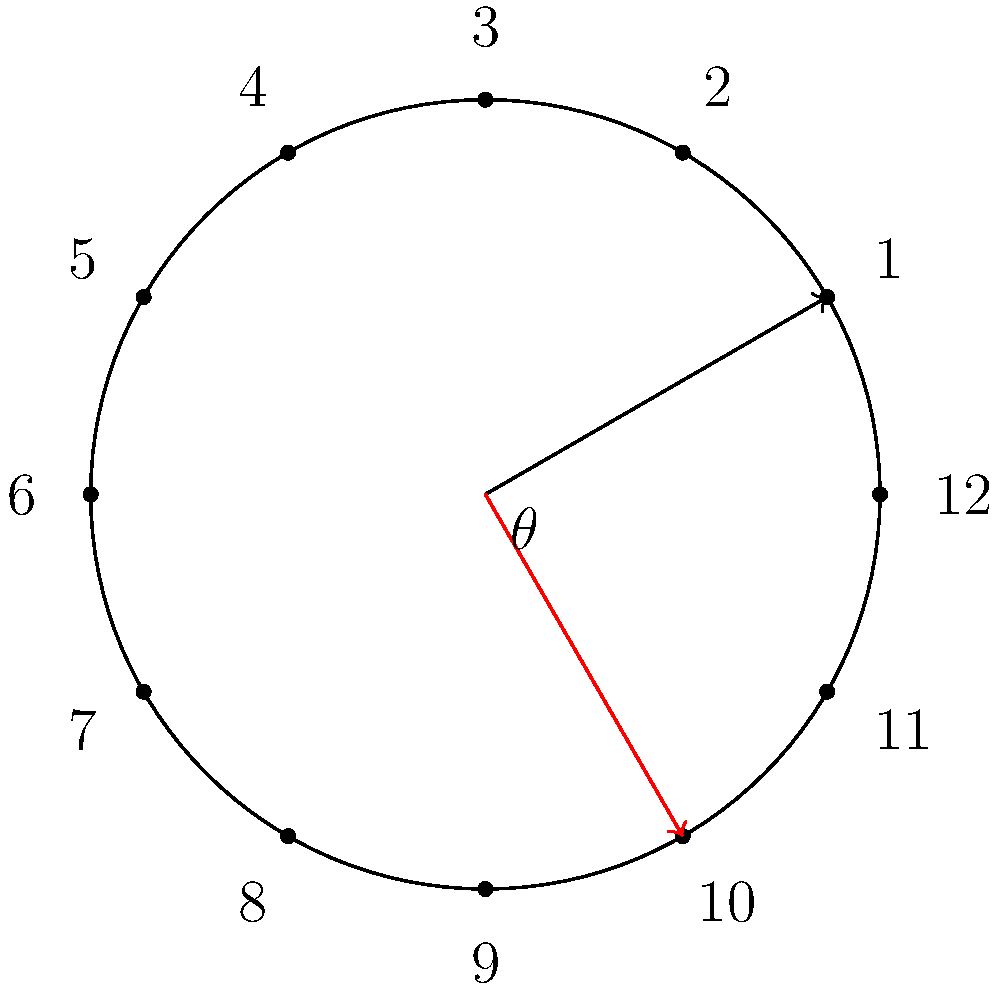The town's clock tower in Phelps County needs maintenance, and the clock face must be rotated. If the hour hand currently points to 1 o'clock and needs to be rotated clockwise by an angle $\theta = 150°$ to point to the correct time, what time will the clock show after the rotation? Let's approach this step-by-step:

1) On a clock face, there are 12 hours, and a full rotation is 360°.
   So, each hour mark represents a rotation of $\frac{360°}{12} = 30°$.

2) The initial position is 1 o'clock, which is $30°$ from 12 o'clock position.

3) The clockwise rotation of $150°$ is equivalent to a counterclockwise rotation of $360° - 150° = 210°$.

4) Total angle from 12 o'clock position after rotation:
   $30° + 210° = 240°$

5) To find the hour, we divide this angle by 30°:
   $\frac{240°}{30°} = 8$

6) Therefore, after rotation, the hour hand will point to 8 o'clock.
Answer: 8 o'clock 